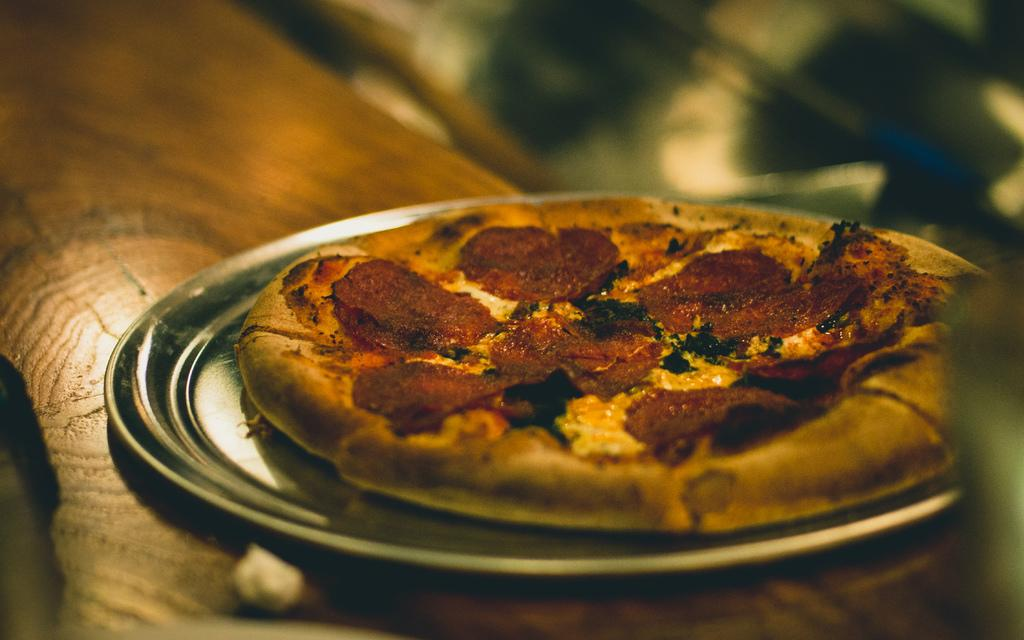What type of food is the main subject of the image? There is a pizza in the image. How is the pizza presented in the image? The pizza is on a plate. Where is the plate with the pizza located? The plate with the pizza is placed on a table. What type of garden can be seen in the image? There is no garden present in the image; it features a pizza on a plate placed on a table. 